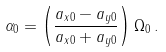Convert formula to latex. <formula><loc_0><loc_0><loc_500><loc_500>\alpha _ { 0 } = \left ( \frac { a _ { x 0 } - a _ { y 0 } } { a _ { x 0 } + a _ { y 0 } } \right ) \Omega _ { 0 } \, .</formula> 